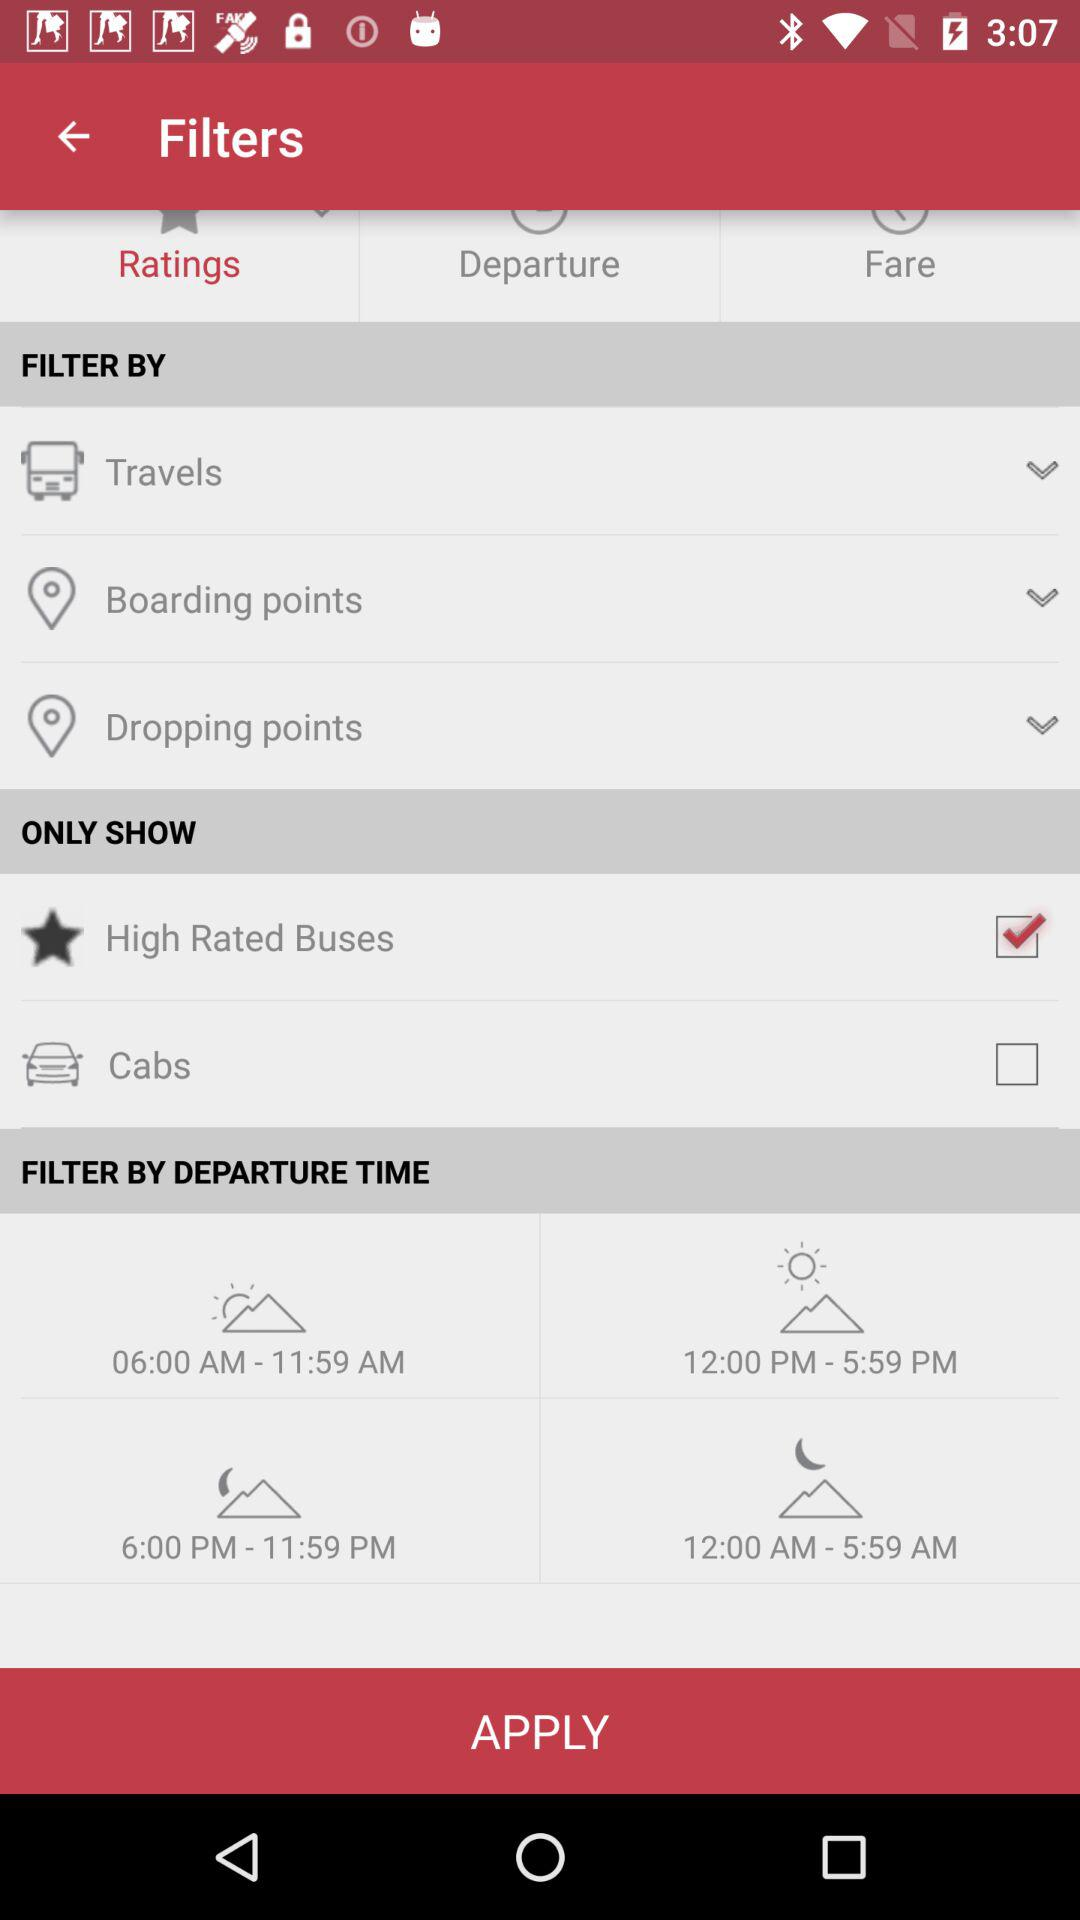What are the departure time options that I can select? The options for departure are "06:00 AM", "12:00 PM", "6:00 PM" and "12:00 AM". 